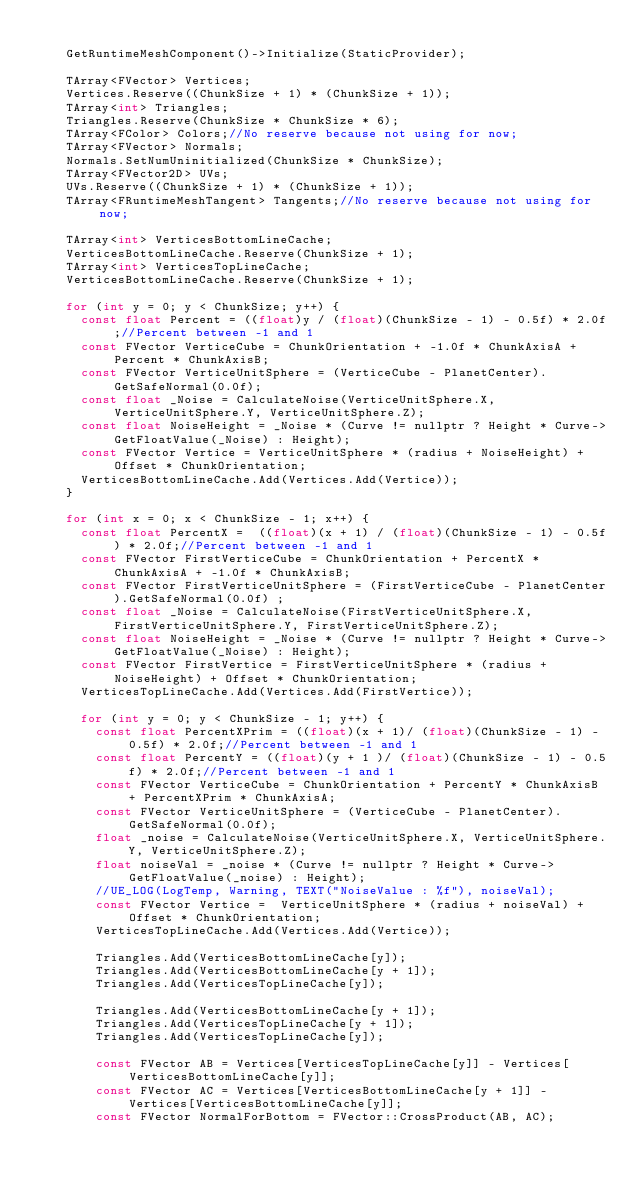Convert code to text. <code><loc_0><loc_0><loc_500><loc_500><_C++_>		
		GetRuntimeMeshComponent()->Initialize(StaticProvider);

		TArray<FVector> Vertices;
		Vertices.Reserve((ChunkSize + 1) * (ChunkSize + 1));
		TArray<int> Triangles;
		Triangles.Reserve(ChunkSize * ChunkSize * 6);
		TArray<FColor> Colors;//No reserve because not using for now;
		TArray<FVector> Normals;
		Normals.SetNumUninitialized(ChunkSize * ChunkSize);
		TArray<FVector2D> UVs;
		UVs.Reserve((ChunkSize + 1) * (ChunkSize + 1));
		TArray<FRuntimeMeshTangent> Tangents;//No reserve because not using for now;

		TArray<int> VerticesBottomLineCache;
		VerticesBottomLineCache.Reserve(ChunkSize + 1);
		TArray<int> VerticesTopLineCache;
		VerticesBottomLineCache.Reserve(ChunkSize + 1);

		for (int y = 0; y < ChunkSize; y++) {
			const float Percent = ((float)y / (float)(ChunkSize - 1) - 0.5f) * 2.0f;//Percent between -1 and 1
			const FVector VerticeCube = ChunkOrientation + -1.0f * ChunkAxisA + Percent * ChunkAxisB;
			const FVector VerticeUnitSphere = (VerticeCube - PlanetCenter).GetSafeNormal(0.0f);
			const float _Noise = CalculateNoise(VerticeUnitSphere.X, VerticeUnitSphere.Y, VerticeUnitSphere.Z);
			const float NoiseHeight = _Noise * (Curve != nullptr ? Height * Curve->GetFloatValue(_Noise) : Height);
			const FVector Vertice = VerticeUnitSphere * (radius + NoiseHeight) + Offset * ChunkOrientation;
			VerticesBottomLineCache.Add(Vertices.Add(Vertice));
		}

		for (int x = 0; x < ChunkSize - 1; x++) {
			const float PercentX =  ((float)(x + 1) / (float)(ChunkSize - 1) - 0.5f) * 2.0f;//Percent between -1 and 1
			const FVector FirstVerticeCube = ChunkOrientation + PercentX * ChunkAxisA + -1.0f * ChunkAxisB;
			const FVector FirstVerticeUnitSphere = (FirstVerticeCube - PlanetCenter).GetSafeNormal(0.0f) ;
			const float _Noise = CalculateNoise(FirstVerticeUnitSphere.X, FirstVerticeUnitSphere.Y, FirstVerticeUnitSphere.Z);
			const float NoiseHeight = _Noise * (Curve != nullptr ? Height * Curve->GetFloatValue(_Noise) : Height);
			const FVector FirstVertice = FirstVerticeUnitSphere * (radius + NoiseHeight) + Offset * ChunkOrientation;
			VerticesTopLineCache.Add(Vertices.Add(FirstVertice));
			
			for (int y = 0; y < ChunkSize - 1; y++) {
				const float PercentXPrim = ((float)(x + 1)/ (float)(ChunkSize - 1) - 0.5f) * 2.0f;//Percent between -1 and 1
				const float PercentY = ((float)(y + 1 )/ (float)(ChunkSize - 1) - 0.5f) * 2.0f;//Percent between -1 and 1
				const FVector VerticeCube = ChunkOrientation + PercentY * ChunkAxisB + PercentXPrim * ChunkAxisA;
				const FVector VerticeUnitSphere = (VerticeCube - PlanetCenter).GetSafeNormal(0.0f);
				float _noise = CalculateNoise(VerticeUnitSphere.X, VerticeUnitSphere.Y, VerticeUnitSphere.Z);
				float noiseVal = _noise * (Curve != nullptr ? Height * Curve->GetFloatValue(_noise) : Height);
				//UE_LOG(LogTemp, Warning, TEXT("NoiseValue : %f"), noiseVal);
				const FVector Vertice =  VerticeUnitSphere * (radius + noiseVal) + Offset * ChunkOrientation;
				VerticesTopLineCache.Add(Vertices.Add(Vertice));

				Triangles.Add(VerticesBottomLineCache[y]);
				Triangles.Add(VerticesBottomLineCache[y + 1]);
				Triangles.Add(VerticesTopLineCache[y]);

				Triangles.Add(VerticesBottomLineCache[y + 1]);
				Triangles.Add(VerticesTopLineCache[y + 1]);
				Triangles.Add(VerticesTopLineCache[y]);

				const FVector AB = Vertices[VerticesTopLineCache[y]] - Vertices[VerticesBottomLineCache[y]];
				const FVector AC = Vertices[VerticesBottomLineCache[y + 1]] - Vertices[VerticesBottomLineCache[y]];
				const FVector NormalForBottom = FVector::CrossProduct(AB, AC);</code> 